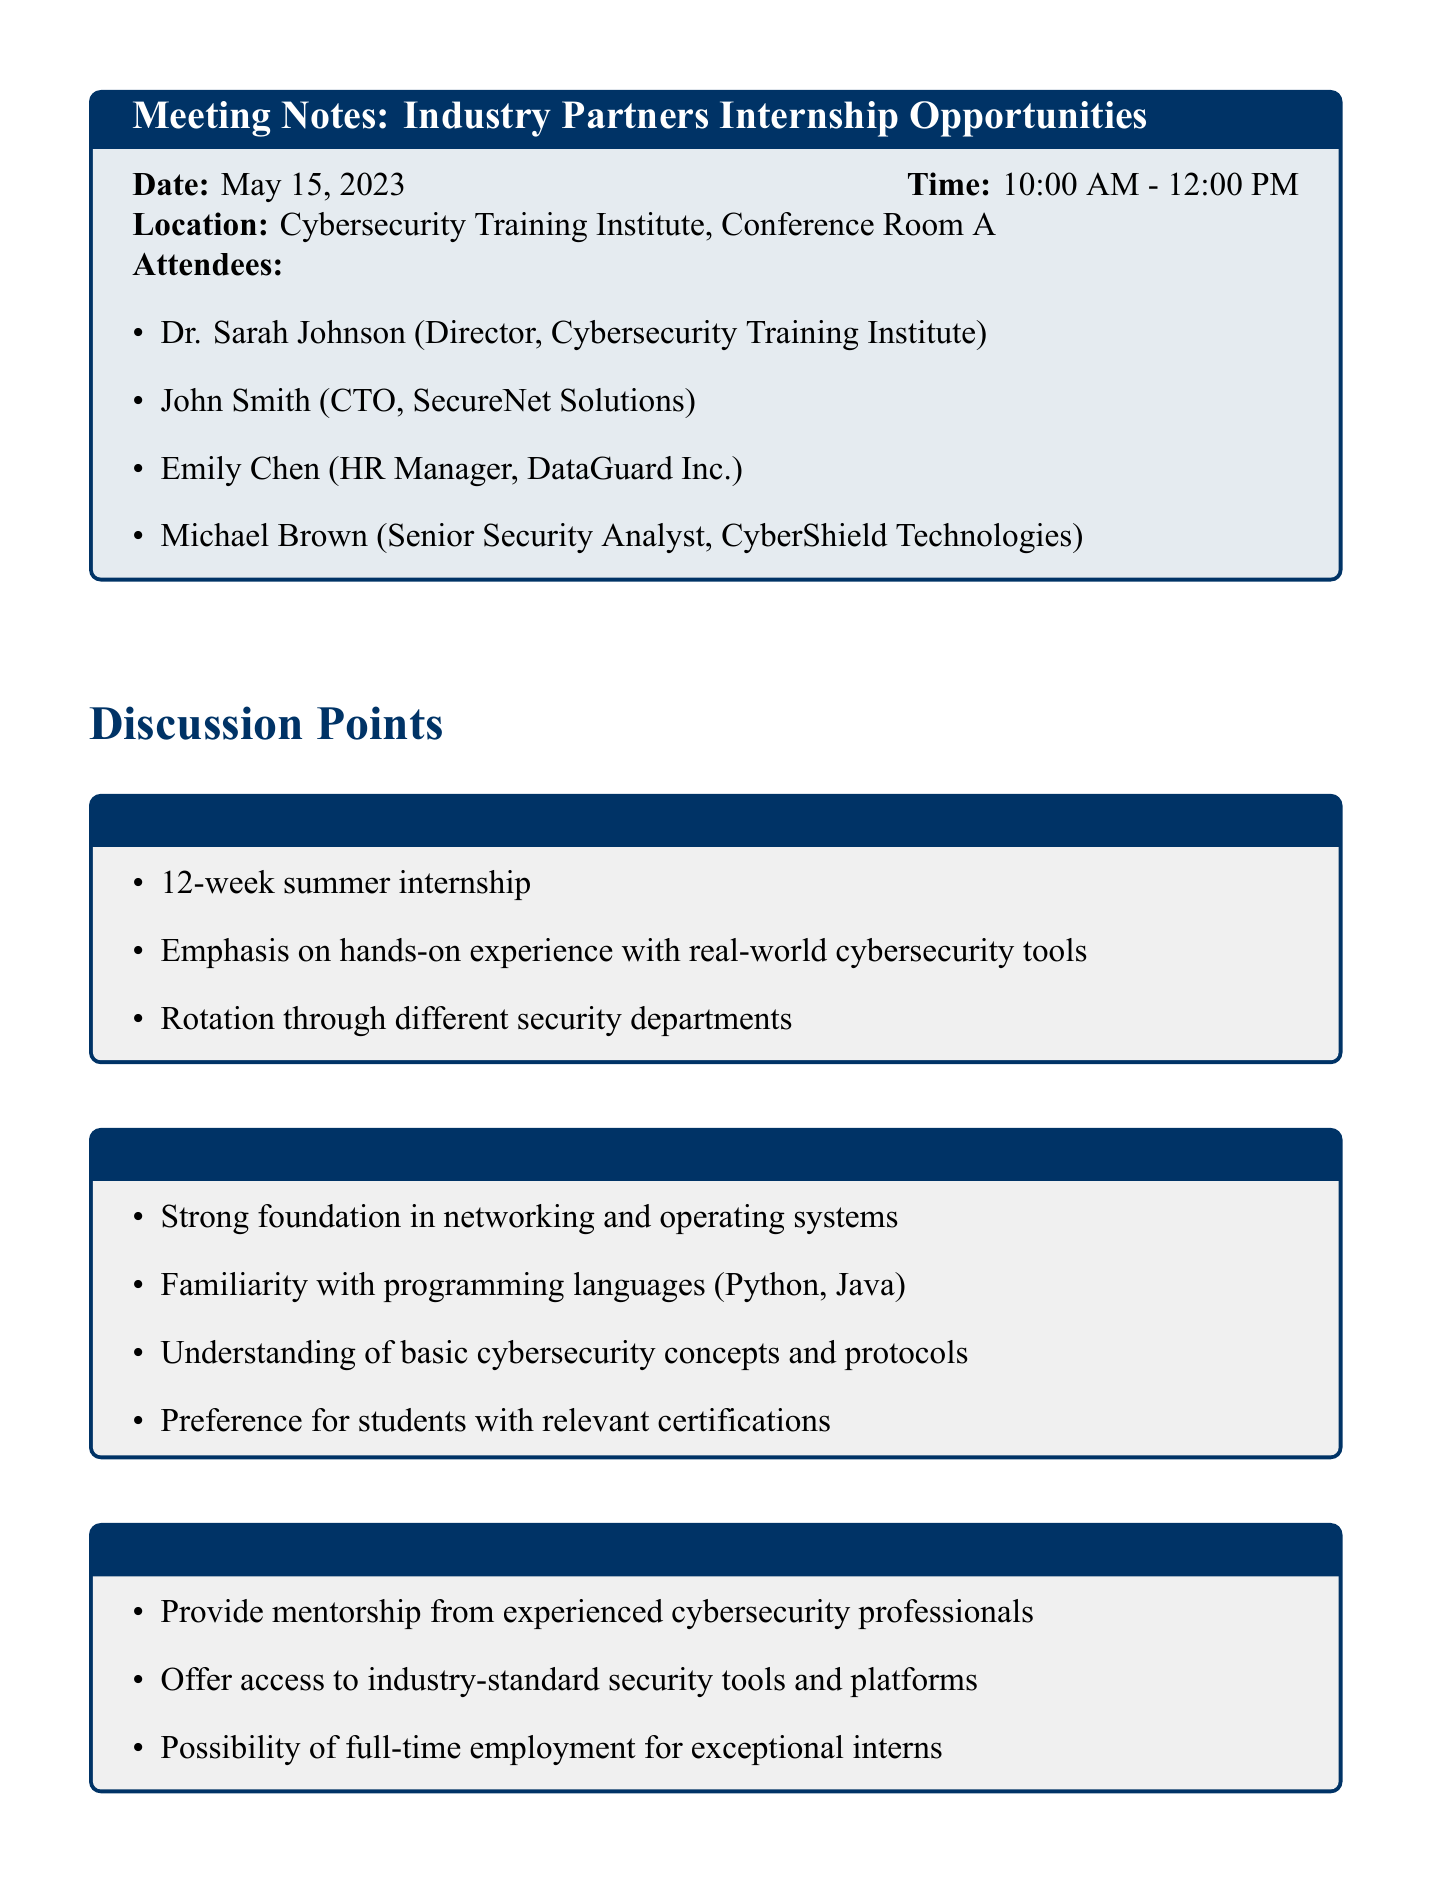What is the date of the meeting? The date of the meeting is explicitly stated in the document under the meeting details section.
Answer: May 15, 2023 Who is the CTO of SecureNet Solutions? The document lists the attendees, including their titles and companies, to identify the CTO.
Answer: John Smith What is the duration of the internship program? The duration of the internship program is mentioned in the discussion points about the internship program structure.
Answer: 12 weeks What skills are preferred for interns? The document outlines the skills required from interns in a dedicated section, detailing specific qualifications.
Answer: Relevant certifications What is one of the commitments of partner companies? The commitments made by partner companies are listed in the discussion points section, which highlights specific responsibilities.
Answer: Provide mentorship What is the purpose of pre-internship training sessions? This information is derived from the Institute's role section, explaining how the institute prepares students for the internship.
Answer: To prepare students When is the next meeting scheduled? The date and time for the next meeting are specified in the final section of the document.
Answer: May 29, 2023 How many attendees are there from industry partner companies? The number of attendees can be counted from the list in the meeting details section.
Answer: Three What is the location of the first meeting? The location is explicitly mentioned in the meeting details section along with the date and time.
Answer: Conference Room A 